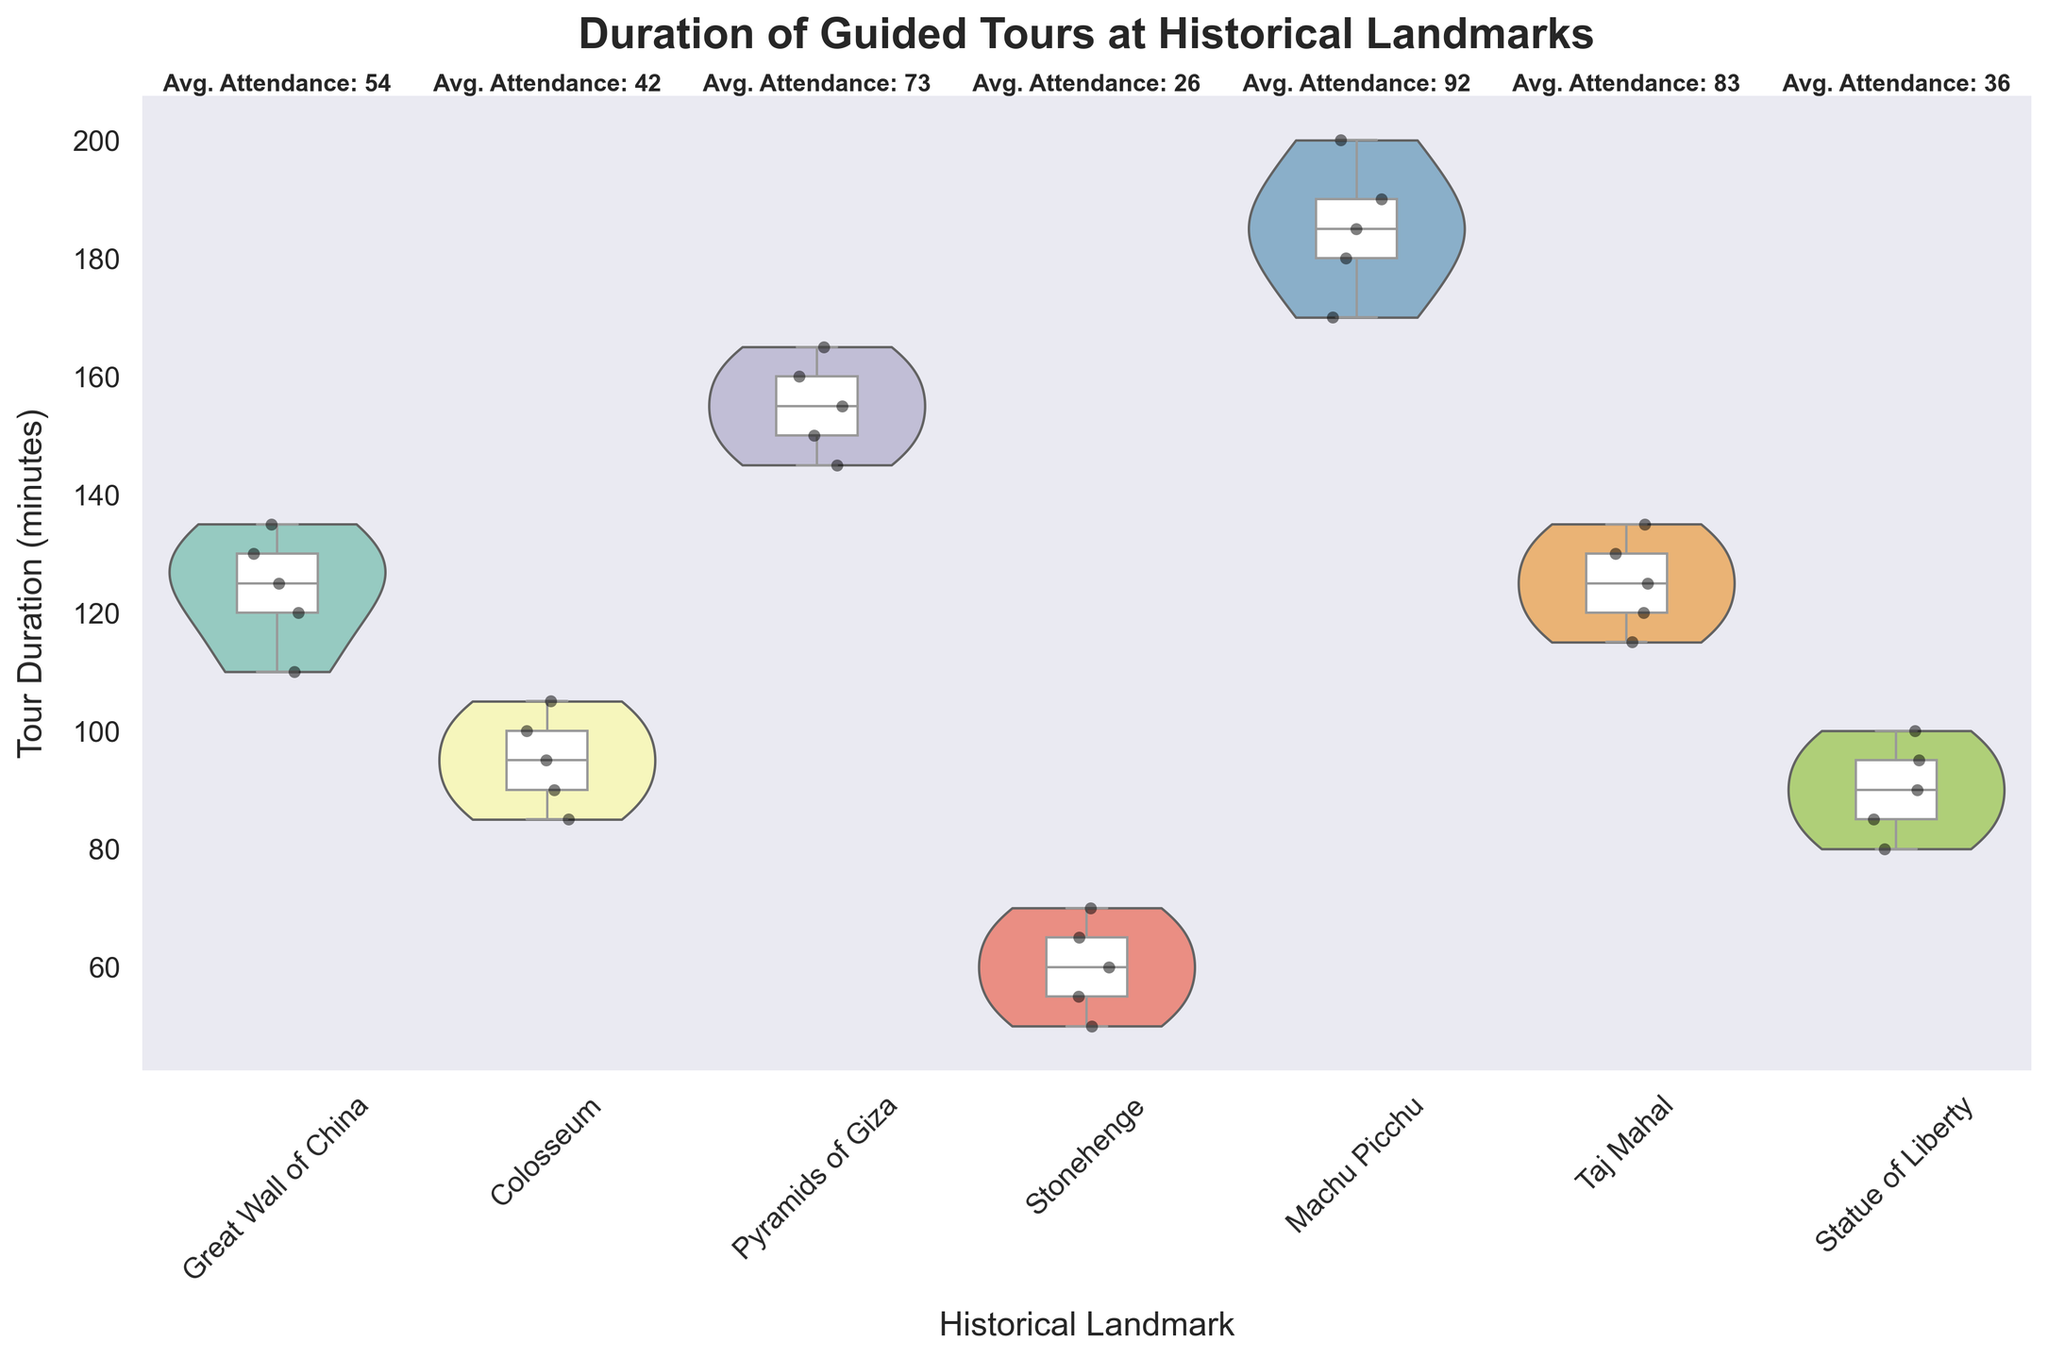What is the title of the figure? The title is usually placed at the top of a figure and can be read directly.
Answer: Duration of Guided Tours at Historical Landmarks Which historical landmark has the longest average tour duration? The average tour duration can be inferred from the position of the central horizontal line (the median) within the box plot. The landmark with the highest median line represents the longest average tour duration.
Answer: Machu Picchu What is the range of tour durations for the Great Wall of China? The range can be determined by looking at the bottom and top of the violin plot for the Great Wall of China.
Answer: 110 to 135 minutes How does the attendance at the Taj Mahal compare to Stonehenge? The average attendance is displayed as a text above each landmark. Comparing these texts shows which landmark has higher average attendance.
Answer: Higher at the Taj Mahal Which landmark has the most variability in tour duration? Variability can be assessed by the width of the violin plot and the length of the whiskers in the box plot. The landmark with the widest violin plot and longest whiskers has the most variability.
Answer: Machu Picchu What is the median tour duration for the Colosseum? The median is represented by the central horizontal line within the box plot for the Colosseum.
Answer: 95 minutes Which landmark has the shortest tour duration? The lowest tour duration can be seen by locating the lowest point of any violin plot in the figure.
Answer: Stonehenge For which landmark is the average attendance closest to 50 people? The average attendance value is shown in text above each landmark. Identify the one closest to 50.
Answer: Great Wall of China Compare the interquartile range (IQR) of the tour duration for the Pyramids of Giza and the Statue of Liberty. The IQR is represented by the height of the box in the box plot. Compare the heights of the boxes for the Pyramids of Giza and the Statue of Liberty to see which is larger.
Answer: Pyramids of Giza has a larger IQR What does the strip of black points in the violin plot represent? Black points in a violin plot often represent individual data points, showing the actual values within the distribution.
Answer: Individual tour durations 